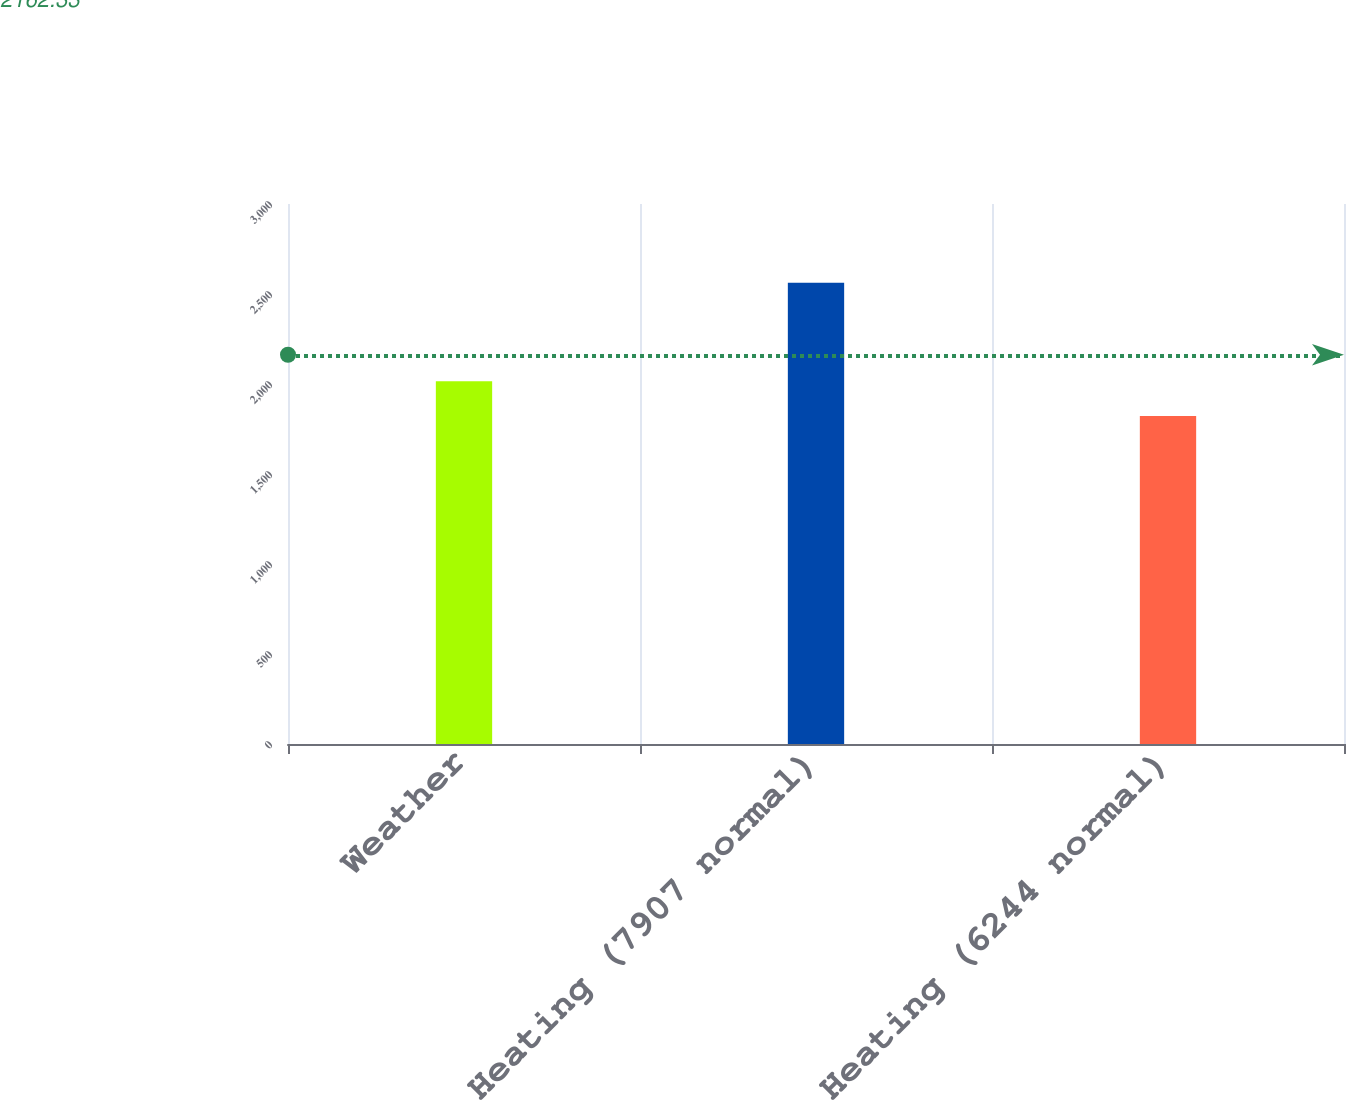Convert chart. <chart><loc_0><loc_0><loc_500><loc_500><bar_chart><fcel>Weather<fcel>Heating (7907 normal)<fcel>Heating (6244 normal)<nl><fcel>2015<fcel>2563<fcel>1822<nl></chart> 